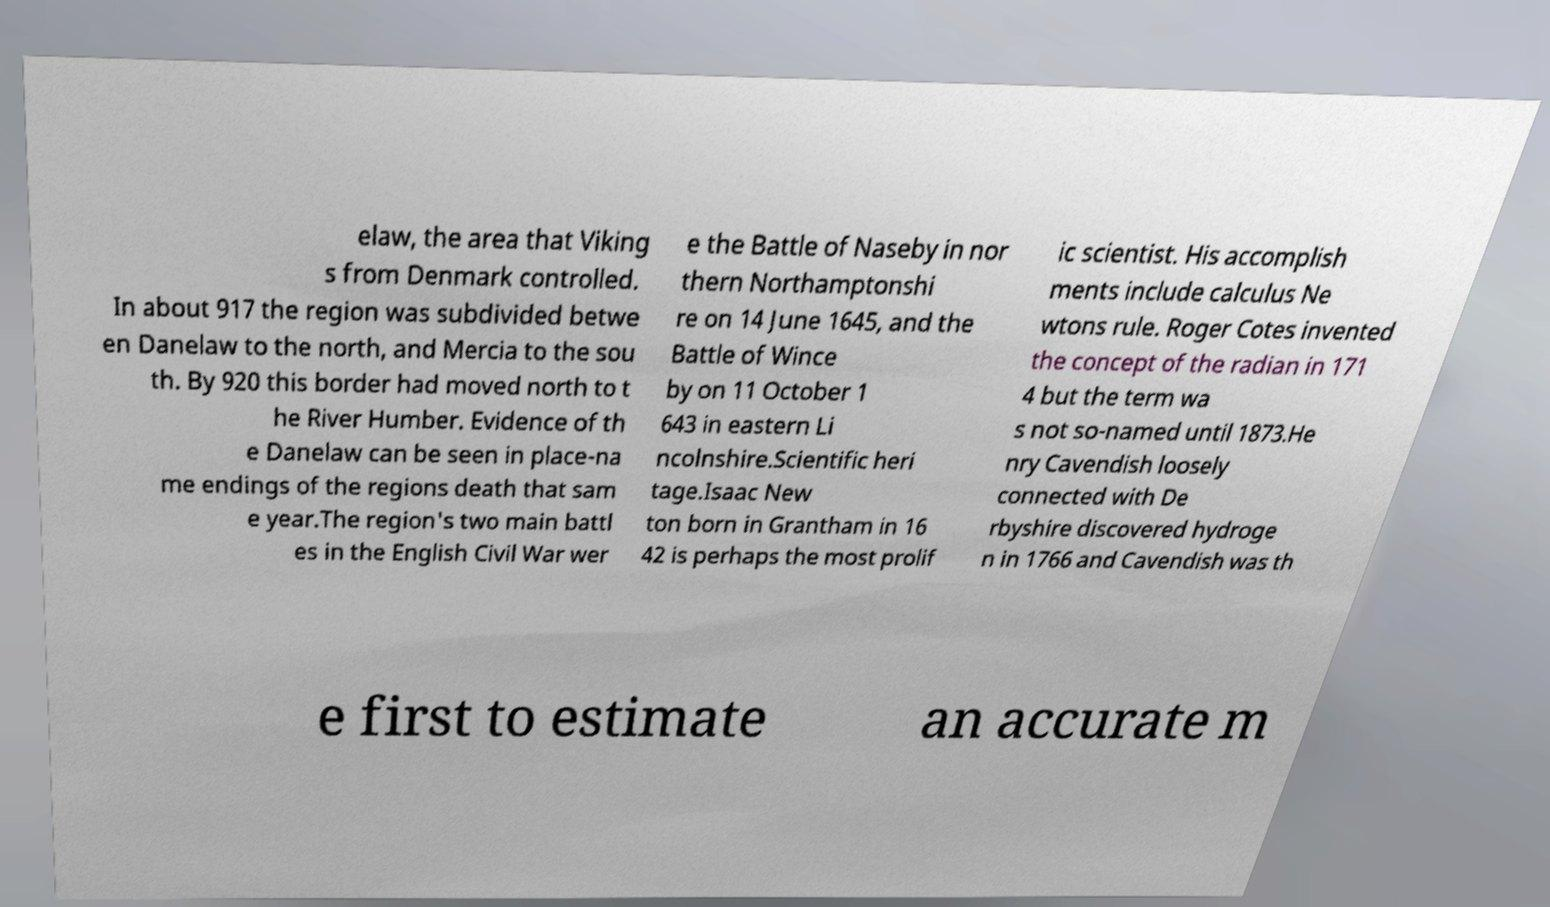Could you extract and type out the text from this image? elaw, the area that Viking s from Denmark controlled. In about 917 the region was subdivided betwe en Danelaw to the north, and Mercia to the sou th. By 920 this border had moved north to t he River Humber. Evidence of th e Danelaw can be seen in place-na me endings of the regions death that sam e year.The region's two main battl es in the English Civil War wer e the Battle of Naseby in nor thern Northamptonshi re on 14 June 1645, and the Battle of Wince by on 11 October 1 643 in eastern Li ncolnshire.Scientific heri tage.Isaac New ton born in Grantham in 16 42 is perhaps the most prolif ic scientist. His accomplish ments include calculus Ne wtons rule. Roger Cotes invented the concept of the radian in 171 4 but the term wa s not so-named until 1873.He nry Cavendish loosely connected with De rbyshire discovered hydroge n in 1766 and Cavendish was th e first to estimate an accurate m 